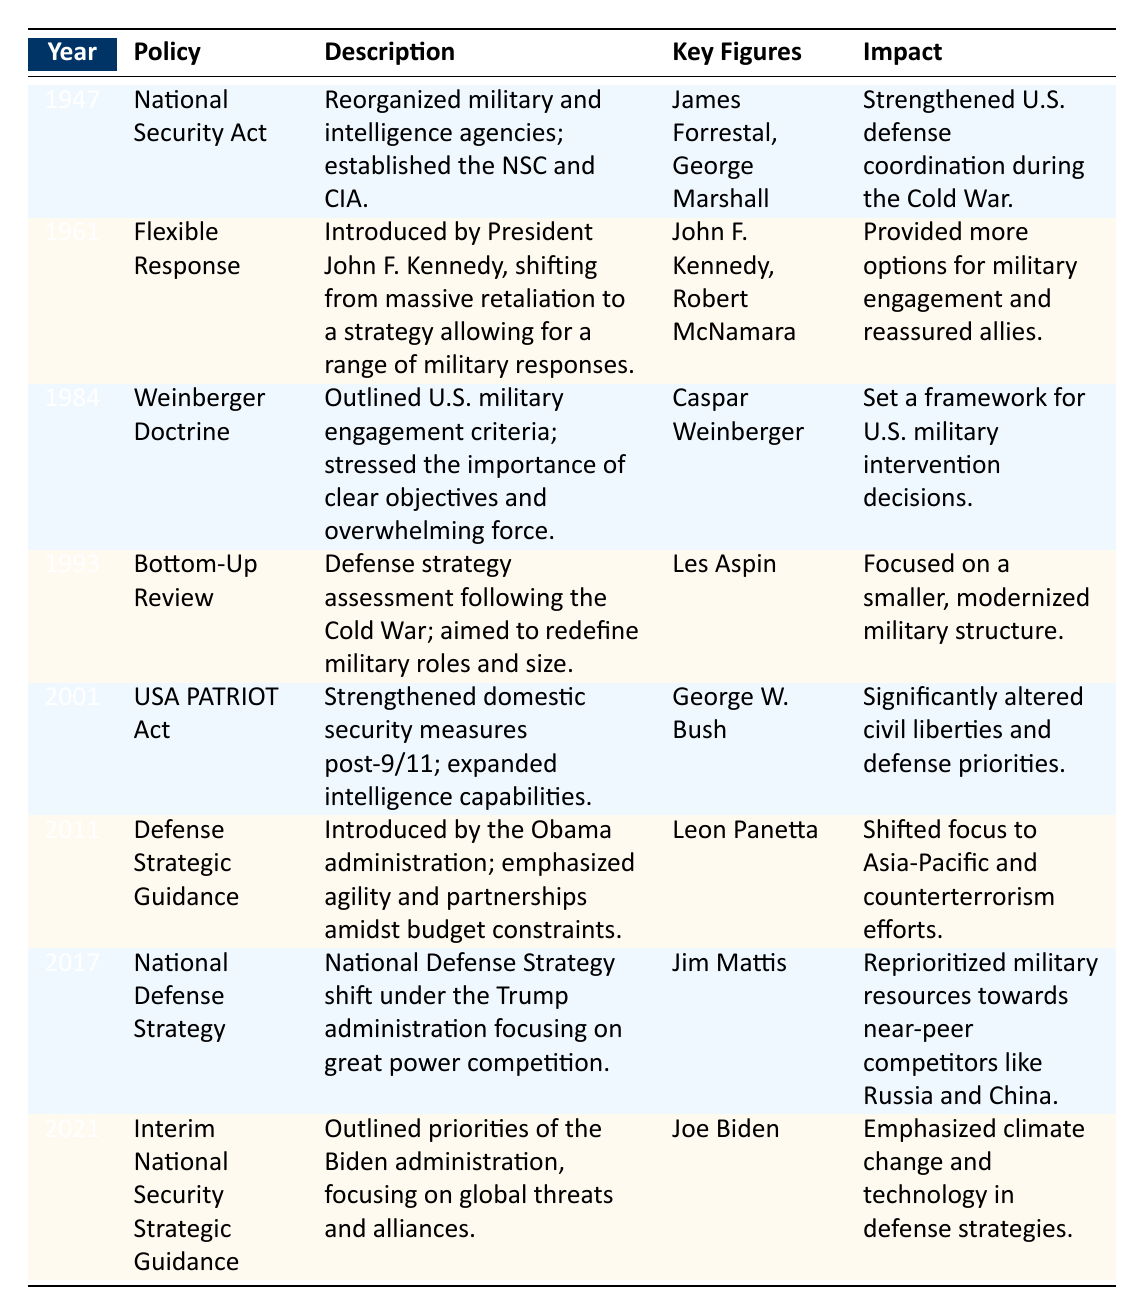What year was the National Security Act implemented? The National Security Act is listed in the table under the year 1947.
Answer: 1947 Who were the key figures associated with the Flexible Response policy? The table lists John F. Kennedy and Robert McNamara as the key figures associated with the Flexible Response policy.
Answer: John F. Kennedy, Robert McNamara Did the USA PATRIOT Act alter civil liberties? The impact section of the table states that the USA PATRIOT Act significantly altered civil liberties and defense priorities. Therefore, it can be concluded that it did indeed alter civil liberties.
Answer: Yes What was the impact of the Weinberger Doctrine? The table notes that the Weinberger Doctrine set a framework for U.S. military intervention decisions, indicating its significance in military strategies.
Answer: Set a framework for U.S. military intervention decisions Which policy emphasized climate change and technology in defense strategies? The Interim National Security Strategic Guidance policy, introduced under the Biden administration, emphasizes climate change and technology as noted in the impact section of the table.
Answer: Interim National Security Strategic Guidance 